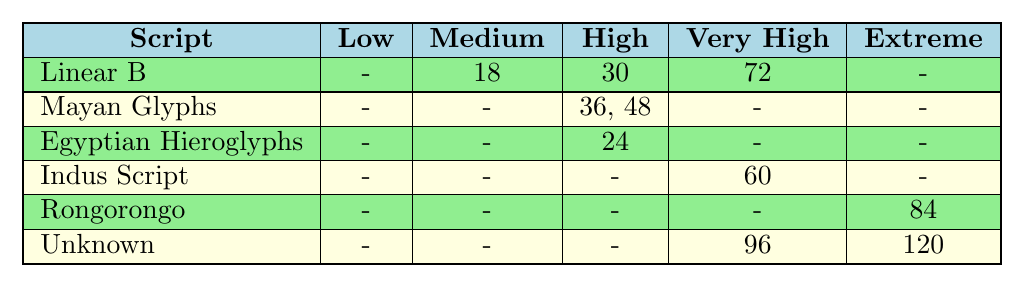What is the time spent on decoding the Indus Script? According to the table, the time spent on decoding the Indus Script is listed as 60 hours.
Answer: 60 hours How many projects have a complexity level of High? The table shows there are 3 projects with a complexity level of High: "Deciphering Palenque Inscriptions", "Unlocking the Rosetta Stone", and "Unraveling the Olmec Writing System".
Answer: 3 projects Which script has the highest time spent on decoding? The table indicates that the "Interpreting the Voynich Manuscript" has the highest time spent on decoding, which is 120 hours.
Answer: Interpreting the Voynich Manuscript What is the average time spent on all projects with Very High complexity? There are 3 projects with Very High complexity: "Decoding the Indus Valley Seals", "Deciphering Linear A" (60 + 72 = 132), and "Cracking the Proto-Elamite Script" (96). Their average is calculated as (60 + 72 + 96)/3 = 76.
Answer: 76 hours Is there any script categorized as Low complexity? The table shows that there are no projects listed under the Low complexity category, indicating that no scripts are at this level.
Answer: No How much longer does it take to decode the "Unraveling Easter Island Tablets" compared to "Cracking the Phaistos Disc"? The time spent on "Unraveling Easter Island Tablets" is 84 hours and on "Cracking the Phaistos Disc" is 18 hours. To find the difference: 84 - 18 = 66 hours.
Answer: 66 hours What percentage of the total time spent on shredding scripts is associated with Extreme complexity? The total time spent across all projects is 60 + 72 + 120 + 84 + 36 + 48 + 24 + 18 + 30 + 96 = 486 hours. The Extreme complexity times are 120 and 84, totaling 204 hours. The percentage is (204 / 486) * 100 ≈ 42%.
Answer: 42% Are there any scripts with Medium complexity that do not have any projects listed? The table shows that there are no scripts with Medium complexity that have any listed projects (as indicated by the dash "-") in the Medium column for "Linear B".
Answer: Yes Which script requires the least amount of time spent overall? By examining the time spent for each script, the script with the least total time spent is "Linear B", which has a total of 48 hours combining all complexities.
Answer: Linear B 